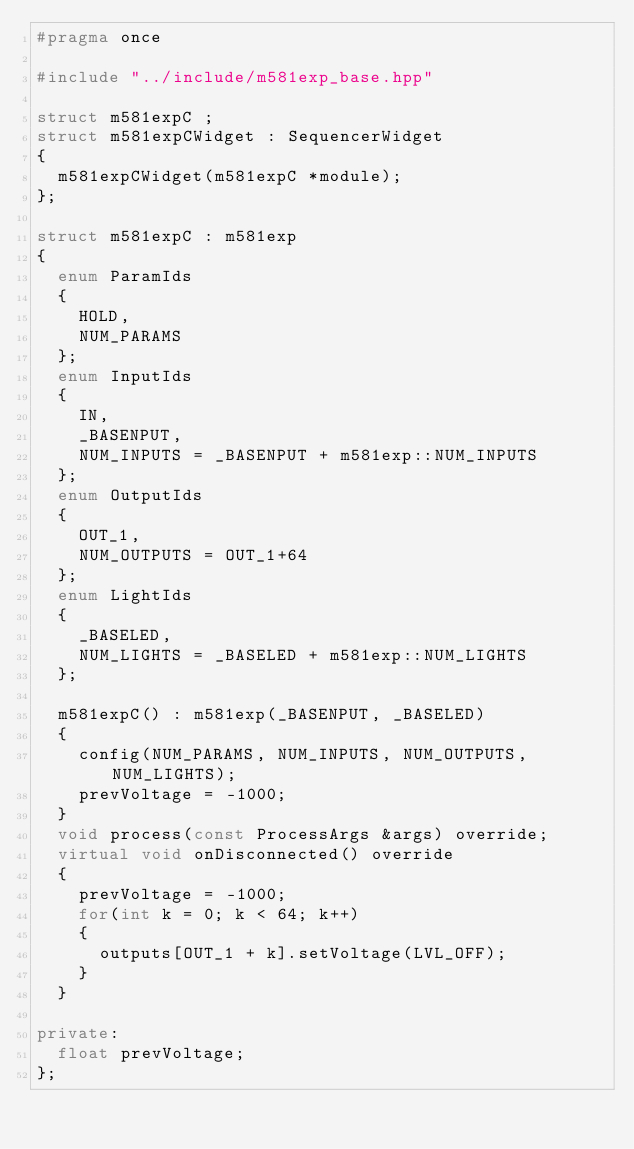Convert code to text. <code><loc_0><loc_0><loc_500><loc_500><_C++_>#pragma once

#include "../include/m581exp_base.hpp"

struct m581expC ;
struct m581expCWidget : SequencerWidget
{
	m581expCWidget(m581expC *module);
};

struct m581expC : m581exp
{
	enum ParamIds
	{
		HOLD,
		NUM_PARAMS
	};
	enum InputIds
	{
		IN,
		_BASENPUT,
		NUM_INPUTS = _BASENPUT + m581exp::NUM_INPUTS
	};
	enum OutputIds
	{
		OUT_1,
		NUM_OUTPUTS = OUT_1+64
	};
	enum LightIds
	{
		_BASELED,
		NUM_LIGHTS = _BASELED + m581exp::NUM_LIGHTS
	};

	m581expC() : m581exp(_BASENPUT, _BASELED)
	{
		config(NUM_PARAMS, NUM_INPUTS, NUM_OUTPUTS, NUM_LIGHTS);
		prevVoltage = -1000;
	}
	void process(const ProcessArgs &args) override;
	virtual void onDisconnected() override
	{
		prevVoltage = -1000;
		for(int k = 0; k < 64; k++)
		{
			outputs[OUT_1 + k].setVoltage(LVL_OFF);
		}
	}

private:
	float prevVoltage;
};

</code> 